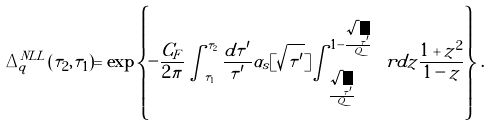Convert formula to latex. <formula><loc_0><loc_0><loc_500><loc_500>\Delta _ { q } ^ { N L L } ( \tau _ { 2 } , \tau _ { 1 } ) = \exp \left \{ - \frac { C _ { F } } { 2 \pi } \int _ { \tau _ { 1 } } ^ { \tau _ { 2 } } \frac { d \tau ^ { \prime } } { \tau ^ { \prime } } \alpha _ { s } [ \sqrt { \tau ^ { \prime } } ] \int _ { \frac { \sqrt { \tau ^ { \prime } } } { Q } } ^ { 1 - \frac { \sqrt { \tau ^ { \prime } } } { Q } } \ r d z \frac { 1 + z ^ { 2 } } { 1 - z } \right \} \, .</formula> 